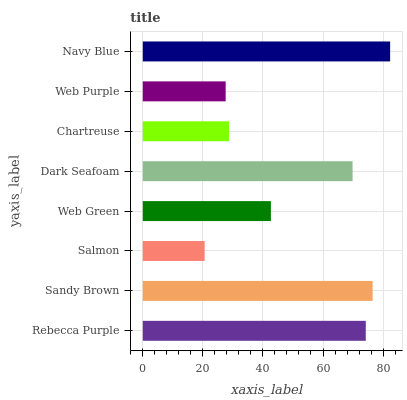Is Salmon the minimum?
Answer yes or no. Yes. Is Navy Blue the maximum?
Answer yes or no. Yes. Is Sandy Brown the minimum?
Answer yes or no. No. Is Sandy Brown the maximum?
Answer yes or no. No. Is Sandy Brown greater than Rebecca Purple?
Answer yes or no. Yes. Is Rebecca Purple less than Sandy Brown?
Answer yes or no. Yes. Is Rebecca Purple greater than Sandy Brown?
Answer yes or no. No. Is Sandy Brown less than Rebecca Purple?
Answer yes or no. No. Is Dark Seafoam the high median?
Answer yes or no. Yes. Is Web Green the low median?
Answer yes or no. Yes. Is Salmon the high median?
Answer yes or no. No. Is Sandy Brown the low median?
Answer yes or no. No. 